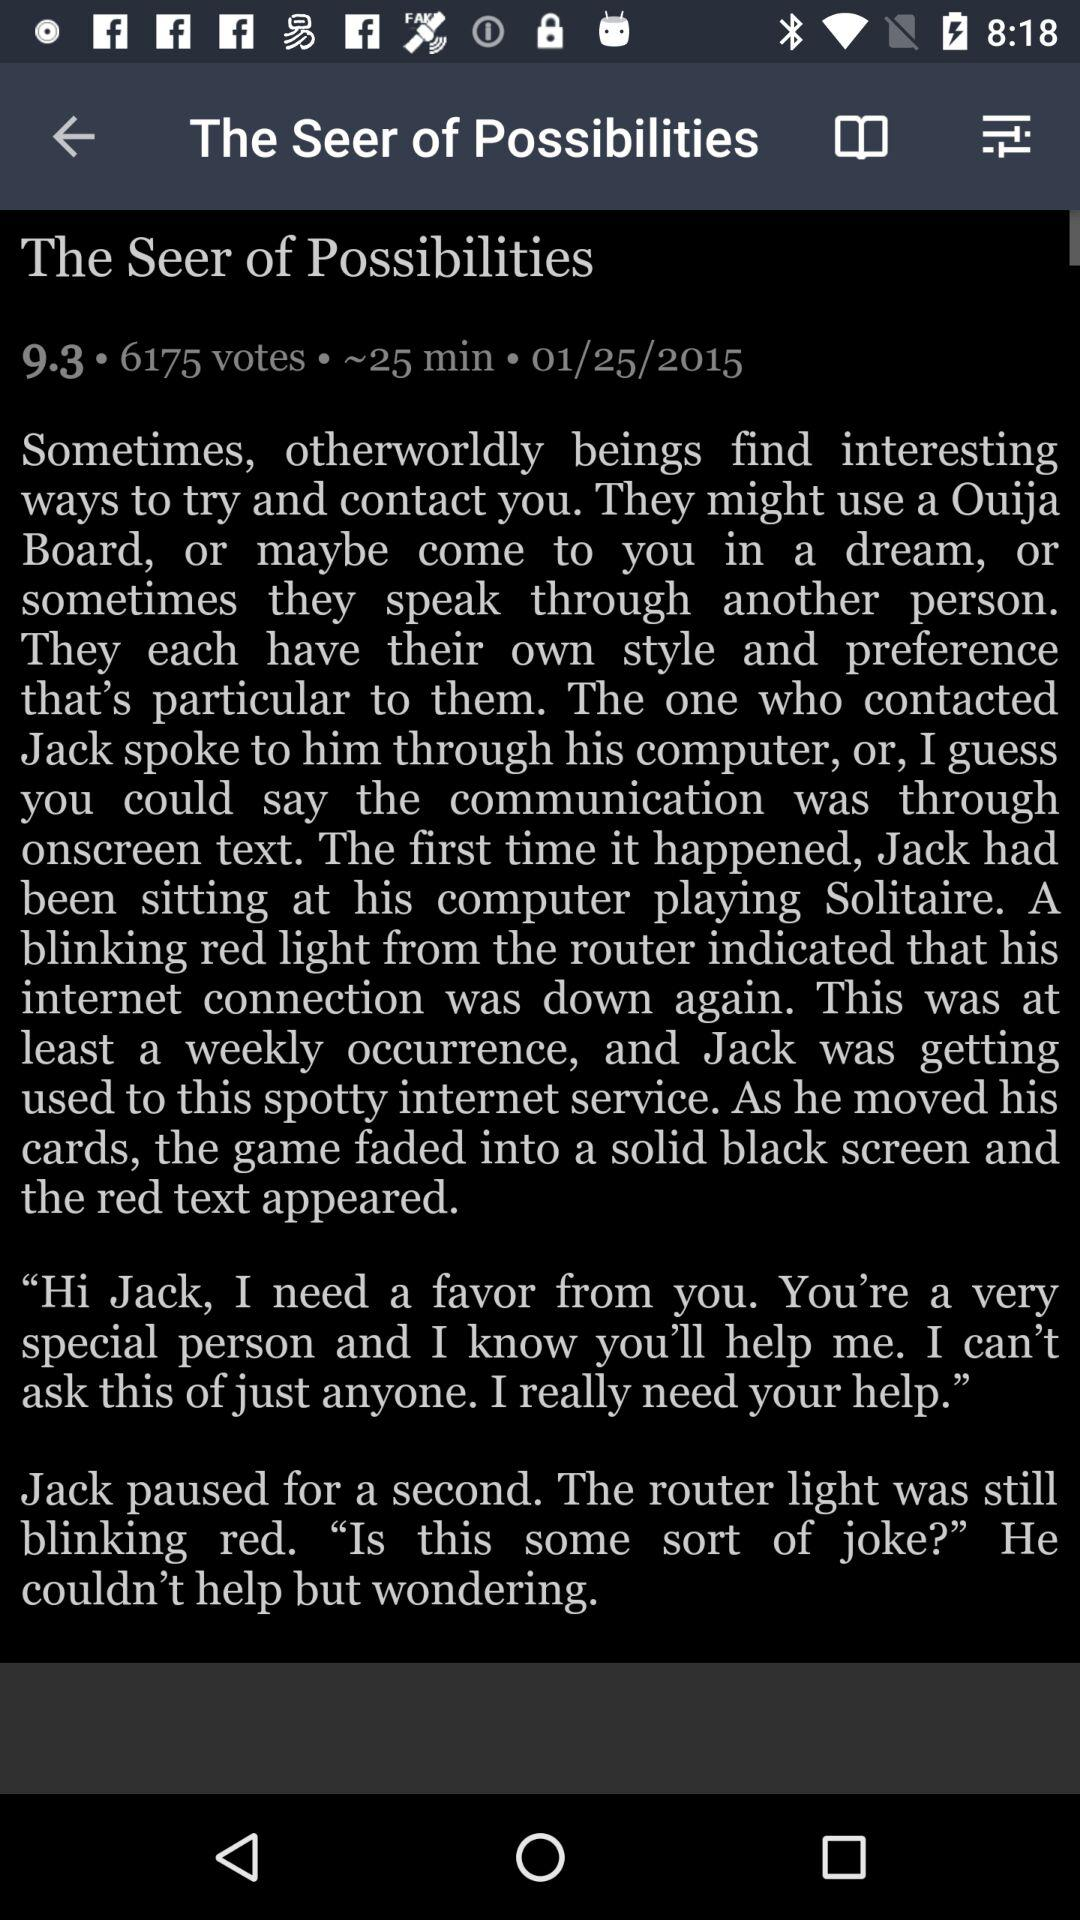What is the headline? The headline is "The Seer of Possibilities". 